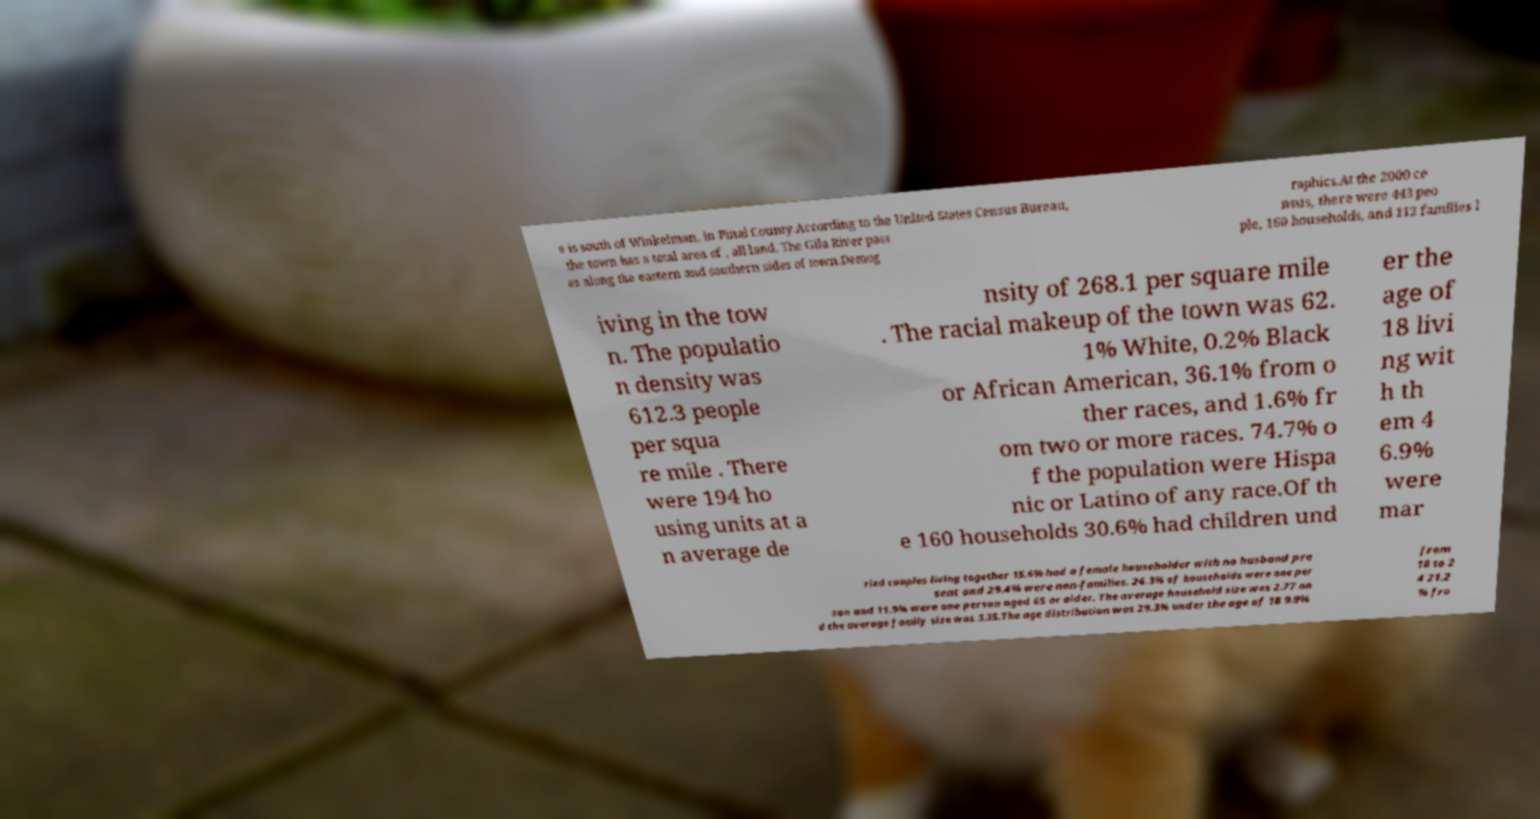What messages or text are displayed in this image? I need them in a readable, typed format. e is south of Winkelman, in Pinal County.According to the United States Census Bureau, the town has a total area of , all land. The Gila River pass es along the eastern and southern sides of town.Demog raphics.At the 2000 ce nsus, there were 443 peo ple, 160 households, and 112 families l iving in the tow n. The populatio n density was 612.3 people per squa re mile . There were 194 ho using units at a n average de nsity of 268.1 per square mile . The racial makeup of the town was 62. 1% White, 0.2% Black or African American, 36.1% from o ther races, and 1.6% fr om two or more races. 74.7% o f the population were Hispa nic or Latino of any race.Of th e 160 households 30.6% had children und er the age of 18 livi ng wit h th em 4 6.9% were mar ried couples living together 15.6% had a female householder with no husband pre sent and 29.4% were non-families. 26.3% of households were one per son and 11.9% were one person aged 65 or older. The average household size was 2.77 an d the average family size was 3.35.The age distribution was 29.3% under the age of 18 9.9% from 18 to 2 4 21.2 % fro 